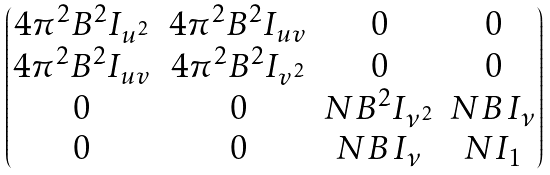<formula> <loc_0><loc_0><loc_500><loc_500>\begin{pmatrix} 4 \pi ^ { 2 } { B } ^ { 2 } I _ { u ^ { 2 } } & 4 \pi ^ { 2 } { B } ^ { 2 } I _ { u v } & 0 & 0 \\ 4 \pi ^ { 2 } { B } ^ { 2 } I _ { u v } & 4 \pi ^ { 2 } { B } ^ { 2 } I _ { v ^ { 2 } } & 0 & 0 \\ 0 & 0 & N B ^ { 2 } I _ { \nu ^ { 2 } } & N B \, I _ { \nu } \\ 0 & 0 & N B \, I _ { \nu } & N I _ { 1 } \end{pmatrix}</formula> 